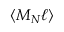Convert formula to latex. <formula><loc_0><loc_0><loc_500><loc_500>\langle M _ { N } \ell \rangle</formula> 